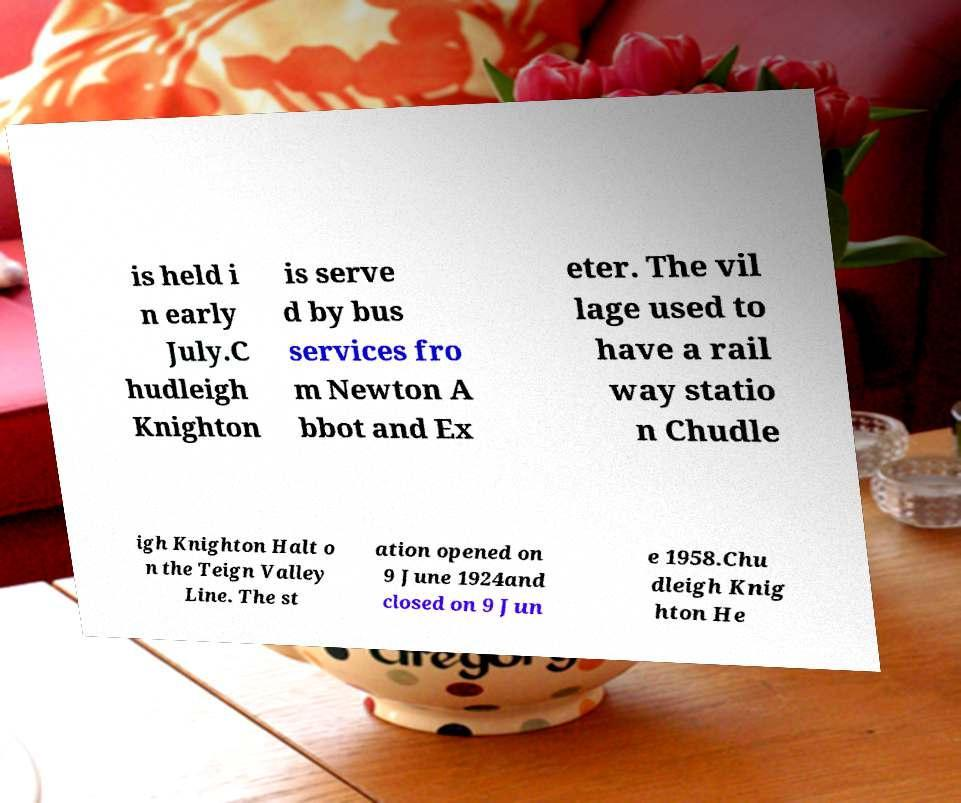Can you accurately transcribe the text from the provided image for me? is held i n early July.C hudleigh Knighton is serve d by bus services fro m Newton A bbot and Ex eter. The vil lage used to have a rail way statio n Chudle igh Knighton Halt o n the Teign Valley Line. The st ation opened on 9 June 1924and closed on 9 Jun e 1958.Chu dleigh Knig hton He 